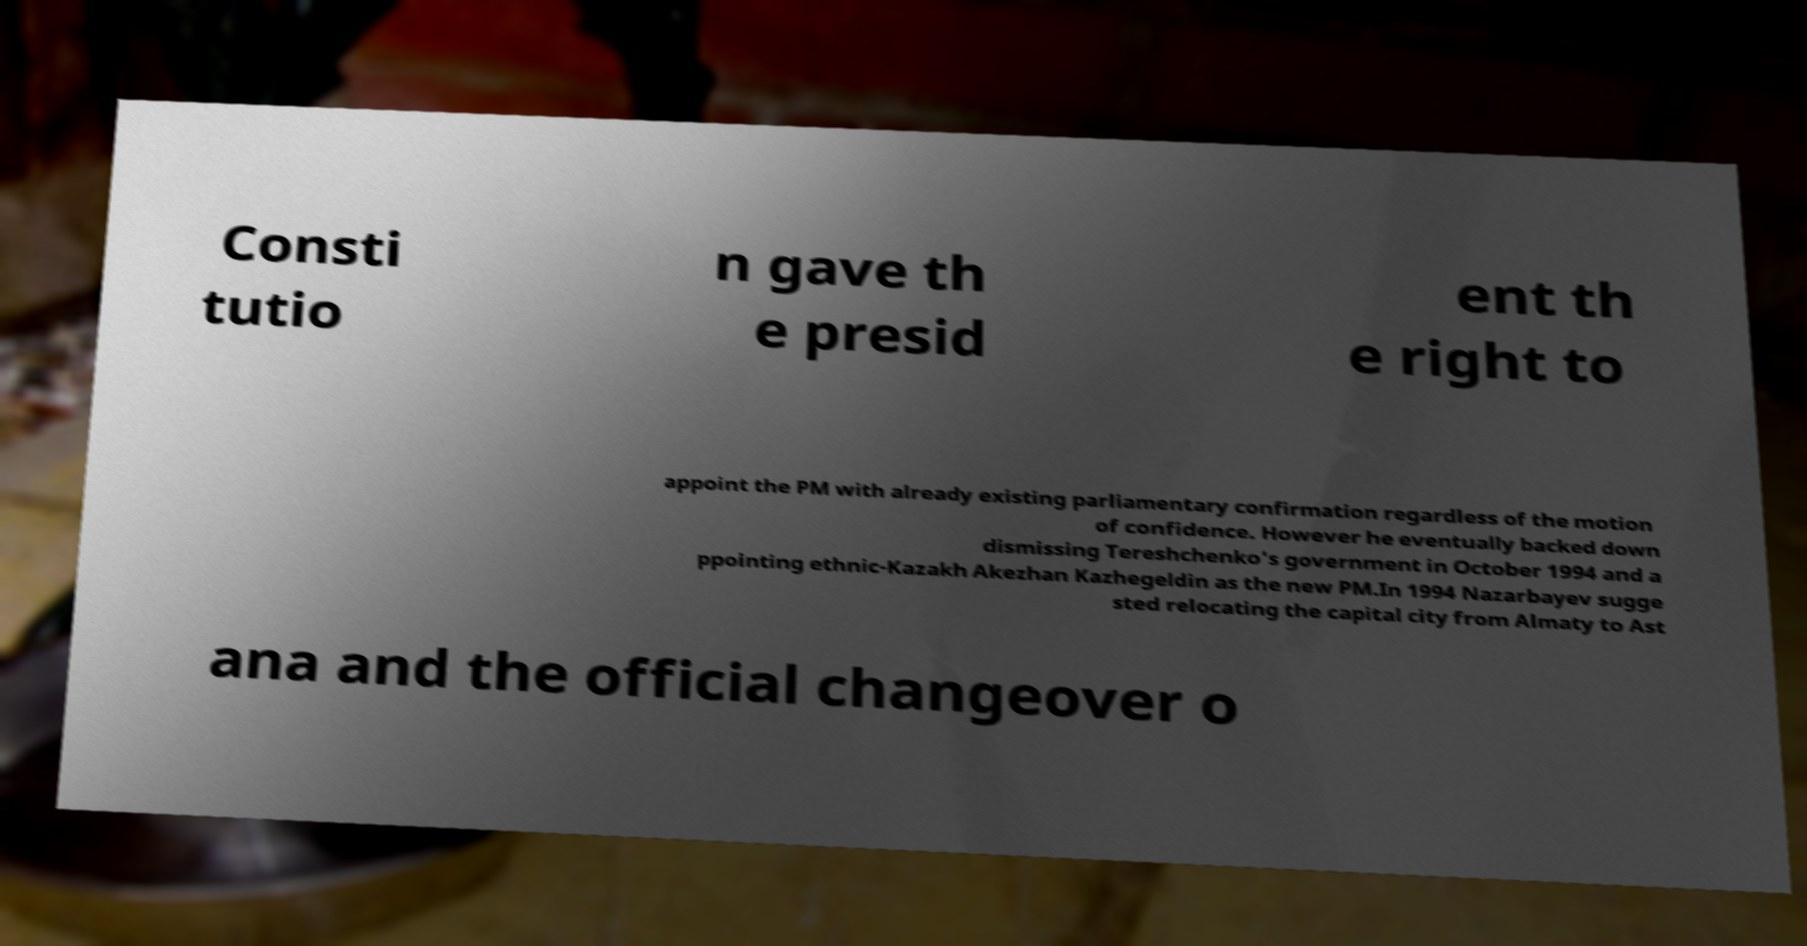Can you accurately transcribe the text from the provided image for me? Consti tutio n gave th e presid ent th e right to appoint the PM with already existing parliamentary confirmation regardless of the motion of confidence. However he eventually backed down dismissing Tereshchenko's government in October 1994 and a ppointing ethnic-Kazakh Akezhan Kazhegeldin as the new PM.In 1994 Nazarbayev sugge sted relocating the capital city from Almaty to Ast ana and the official changeover o 